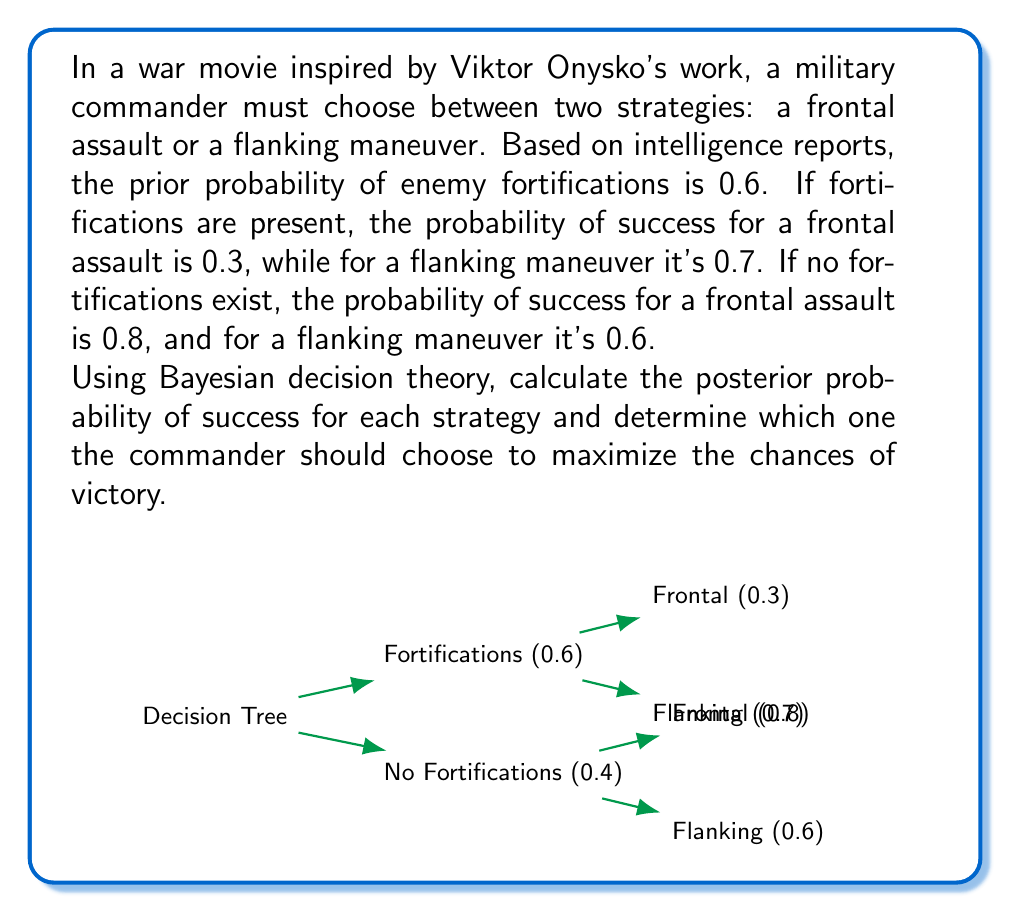Help me with this question. Let's approach this problem step-by-step using Bayesian decision theory:

1) Define events:
   F: Fortifications present
   S: Success of the operation

2) Given probabilities:
   P(F) = 0.6
   P(¬F) = 1 - 0.6 = 0.4
   P(S|F, Frontal) = 0.3
   P(S|F, Flanking) = 0.7
   P(S|¬F, Frontal) = 0.8
   P(S|¬F, Flanking) = 0.6

3) For Frontal Assault:
   P(S|Frontal) = P(S|F, Frontal) * P(F) + P(S|¬F, Frontal) * P(¬F)
                = 0.3 * 0.6 + 0.8 * 0.4
                = 0.18 + 0.32
                = 0.50

4) For Flanking Maneuver:
   P(S|Flanking) = P(S|F, Flanking) * P(F) + P(S|¬F, Flanking) * P(¬F)
                 = 0.7 * 0.6 + 0.6 * 0.4
                 = 0.42 + 0.24
                 = 0.66

5) Comparing the posterior probabilities:
   P(S|Flanking) > P(S|Frontal)
   0.66 > 0.50

Therefore, the flanking maneuver has a higher probability of success (0.66 or 66%) compared to the frontal assault (0.50 or 50%).
Answer: Choose the flanking maneuver (66% success probability). 